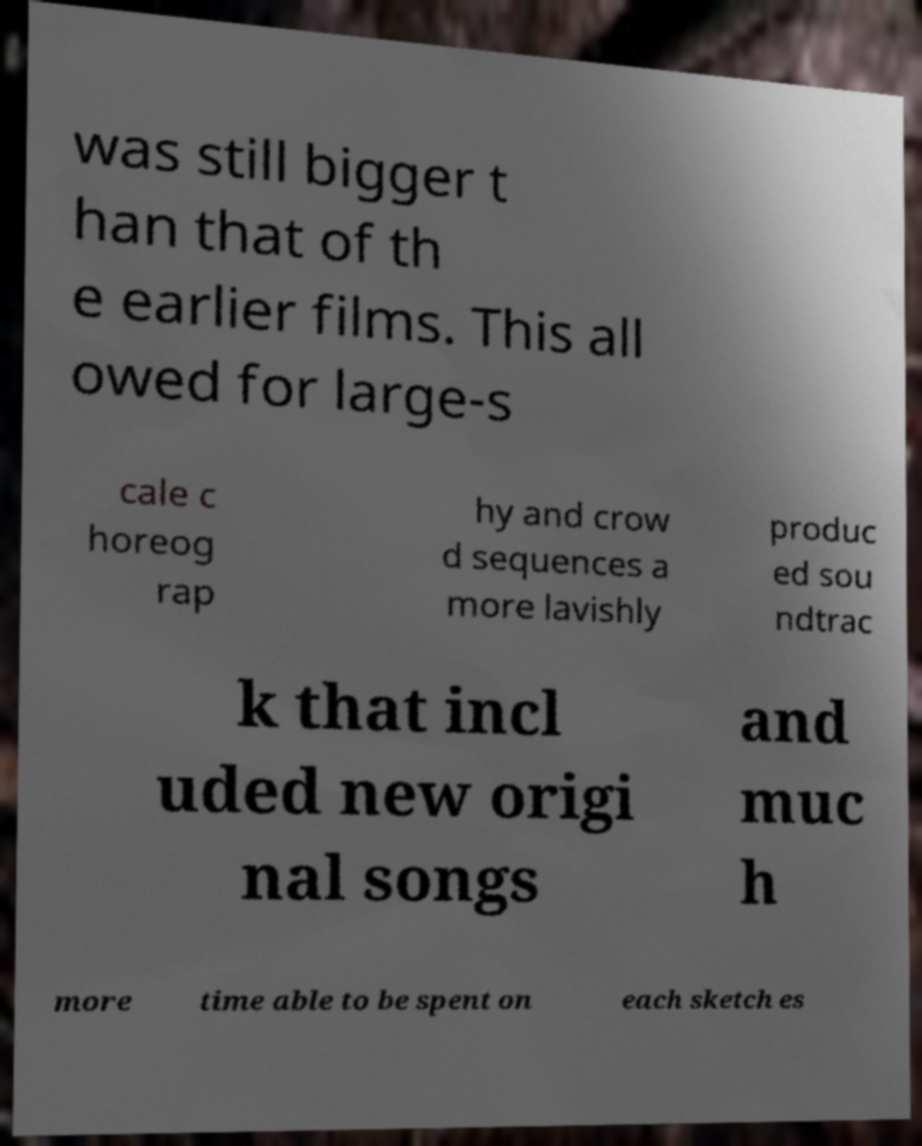There's text embedded in this image that I need extracted. Can you transcribe it verbatim? was still bigger t han that of th e earlier films. This all owed for large-s cale c horeog rap hy and crow d sequences a more lavishly produc ed sou ndtrac k that incl uded new origi nal songs and muc h more time able to be spent on each sketch es 